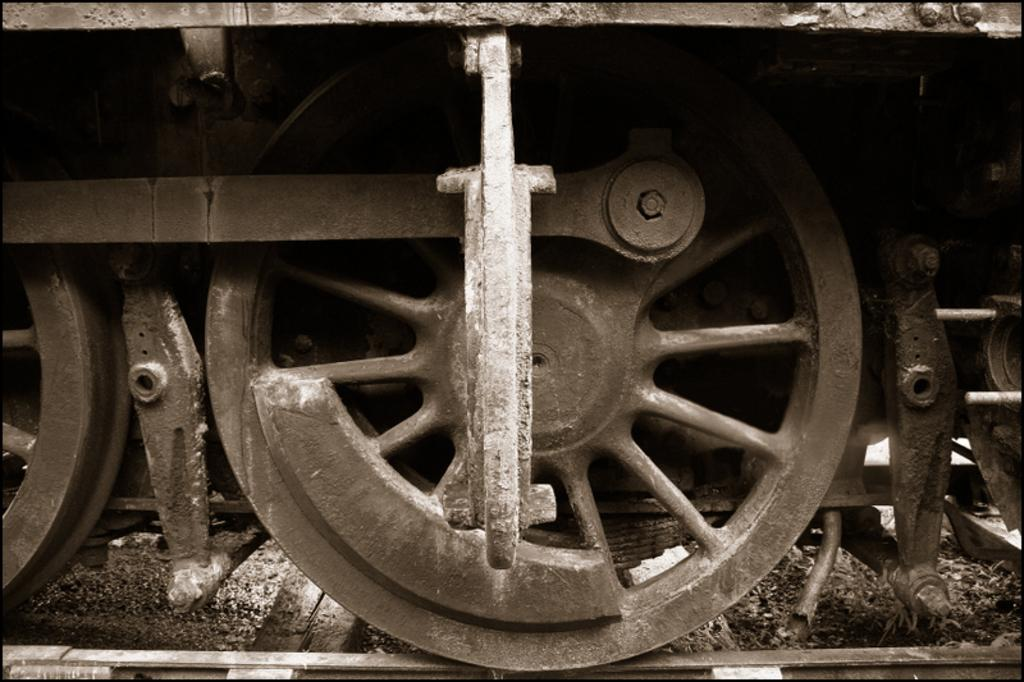What type of wheels are shown in the image? There are train wheels in the image. What is located at the bottom of the image? There is a railway track visible at the bottom of the image. What type of wind can be seen blowing through the train wheels in the image? There is no wind present in the image; it only shows train wheels and a railway track. How many cherries are sitting on top of the train wheels in the image? There are no cherries present in the image. 